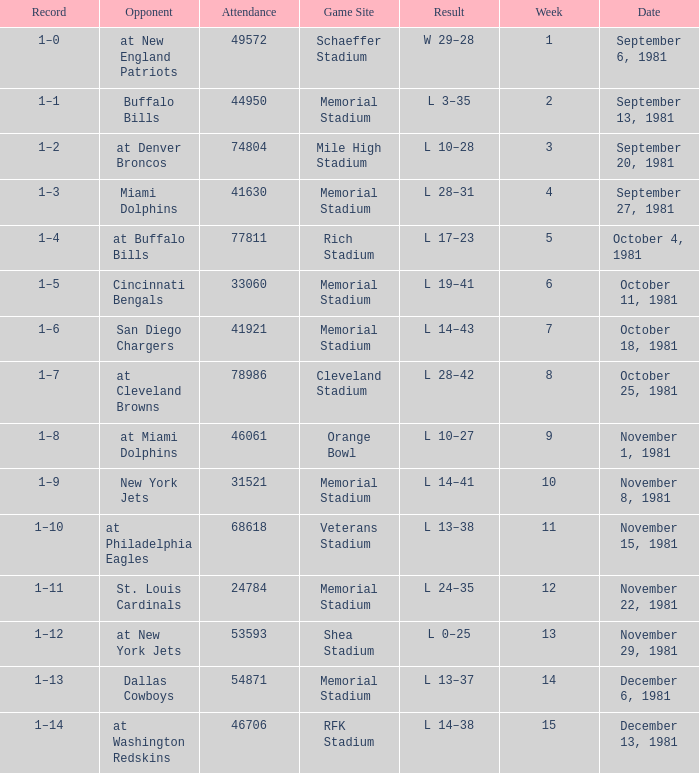Could you help me parse every detail presented in this table? {'header': ['Record', 'Opponent', 'Attendance', 'Game Site', 'Result', 'Week', 'Date'], 'rows': [['1–0', 'at New England Patriots', '49572', 'Schaeffer Stadium', 'W 29–28', '1', 'September 6, 1981'], ['1–1', 'Buffalo Bills', '44950', 'Memorial Stadium', 'L 3–35', '2', 'September 13, 1981'], ['1–2', 'at Denver Broncos', '74804', 'Mile High Stadium', 'L 10–28', '3', 'September 20, 1981'], ['1–3', 'Miami Dolphins', '41630', 'Memorial Stadium', 'L 28–31', '4', 'September 27, 1981'], ['1–4', 'at Buffalo Bills', '77811', 'Rich Stadium', 'L 17–23', '5', 'October 4, 1981'], ['1–5', 'Cincinnati Bengals', '33060', 'Memorial Stadium', 'L 19–41', '6', 'October 11, 1981'], ['1–6', 'San Diego Chargers', '41921', 'Memorial Stadium', 'L 14–43', '7', 'October 18, 1981'], ['1–7', 'at Cleveland Browns', '78986', 'Cleveland Stadium', 'L 28–42', '8', 'October 25, 1981'], ['1–8', 'at Miami Dolphins', '46061', 'Orange Bowl', 'L 10–27', '9', 'November 1, 1981'], ['1–9', 'New York Jets', '31521', 'Memorial Stadium', 'L 14–41', '10', 'November 8, 1981'], ['1–10', 'at Philadelphia Eagles', '68618', 'Veterans Stadium', 'L 13–38', '11', 'November 15, 1981'], ['1–11', 'St. Louis Cardinals', '24784', 'Memorial Stadium', 'L 24–35', '12', 'November 22, 1981'], ['1–12', 'at New York Jets', '53593', 'Shea Stadium', 'L 0–25', '13', 'November 29, 1981'], ['1–13', 'Dallas Cowboys', '54871', 'Memorial Stadium', 'L 13–37', '14', 'December 6, 1981'], ['1–14', 'at Washington Redskins', '46706', 'RFK Stadium', 'L 14–38', '15', 'December 13, 1981']]} When it is week 2 what is the record? 1–1. 